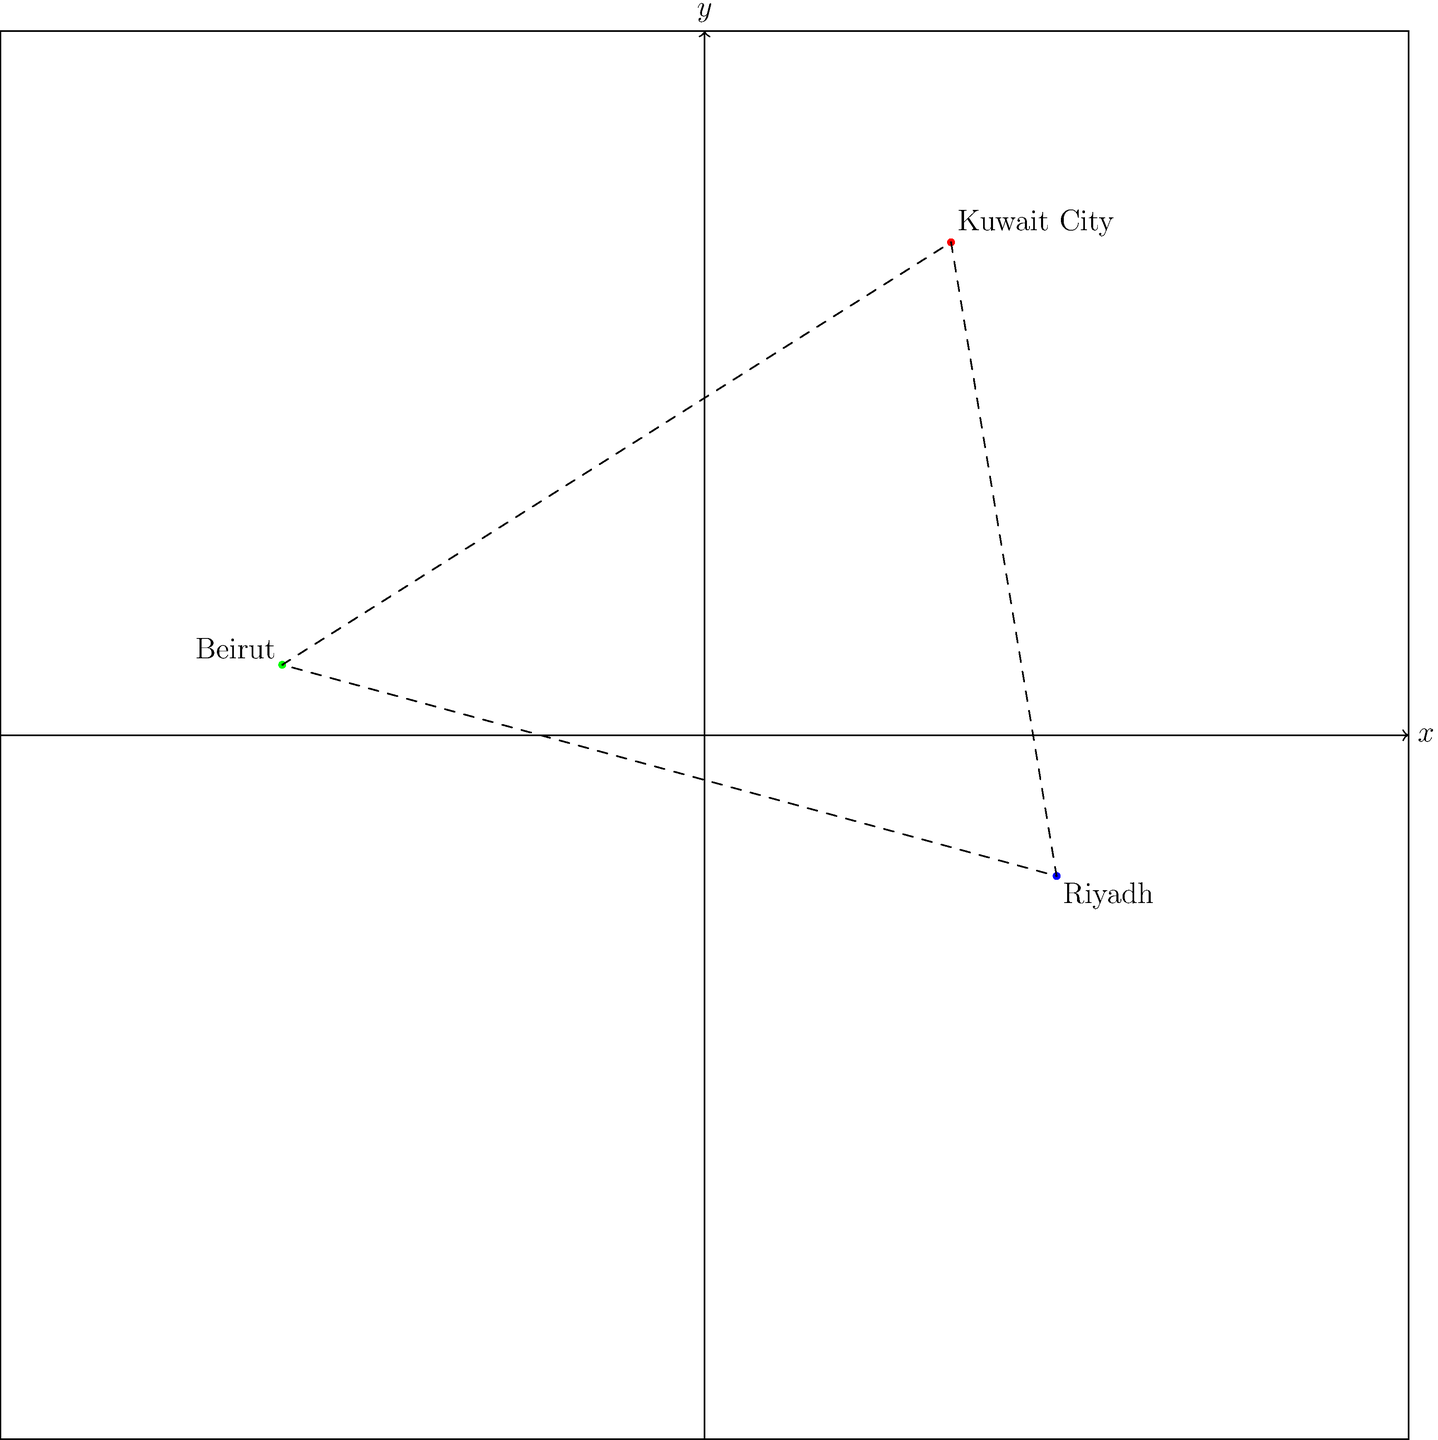Given the geographic coordinates of three Middle Eastern cities converted to Cartesian coordinates (x, y) on a 20x20 grid centered at (0,0):

Kuwait City (29.3759° N, 47.9774° E): (3.5, 7)
Riyadh (24.7136° N, 46.6753° E): (5, -2)
Beirut (33.8938° N, 35.5018° E): (-6, 1)

Calculate the area of the triangle formed by these three points in square units. To calculate the area of a triangle given the coordinates of its vertices, we can use the formula:

$$ \text{Area} = \frac{1}{2}|x_1(y_2 - y_3) + x_2(y_3 - y_1) + x_3(y_1 - y_2)| $$

Where $(x_1, y_1)$, $(x_2, y_2)$, and $(x_3, y_3)$ are the coordinates of the three vertices.

Let's assign the coordinates:
$(x_1, y_1) = (3.5, 7)$ for Kuwait City
$(x_2, y_2) = (5, -2)$ for Riyadh
$(x_3, y_3) = (-6, 1)$ for Beirut

Now, let's substitute these values into the formula:

$$ \text{Area} = \frac{1}{2}|3.5(-2 - 1) + 5(1 - 7) + (-6)(7 - (-2))| $$

$$ = \frac{1}{2}|3.5(-3) + 5(-6) + (-6)(9)| $$

$$ = \frac{1}{2}|-10.5 - 30 - 54| $$

$$ = \frac{1}{2}|-94.5| $$

$$ = \frac{1}{2}(94.5) $$

$$ = 47.25 $$

Therefore, the area of the triangle is 47.25 square units.
Answer: 47.25 square units 